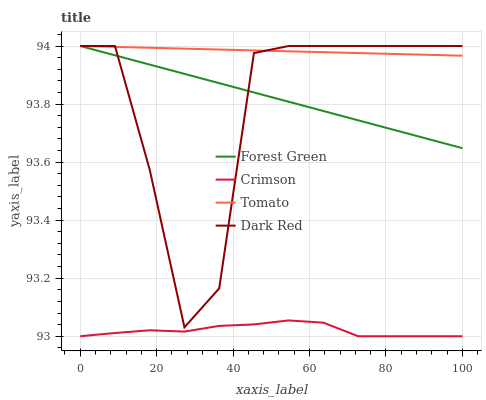Does Forest Green have the minimum area under the curve?
Answer yes or no. No. Does Forest Green have the maximum area under the curve?
Answer yes or no. No. Is Forest Green the smoothest?
Answer yes or no. No. Is Forest Green the roughest?
Answer yes or no. No. Does Forest Green have the lowest value?
Answer yes or no. No. Is Crimson less than Forest Green?
Answer yes or no. Yes. Is Dark Red greater than Crimson?
Answer yes or no. Yes. Does Crimson intersect Forest Green?
Answer yes or no. No. 